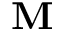<formula> <loc_0><loc_0><loc_500><loc_500>{ M }</formula> 